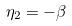<formula> <loc_0><loc_0><loc_500><loc_500>\eta _ { 2 } = - \beta</formula> 